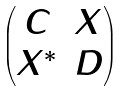Convert formula to latex. <formula><loc_0><loc_0><loc_500><loc_500>\begin{pmatrix} C & X \\ X ^ { * } & D \end{pmatrix}</formula> 